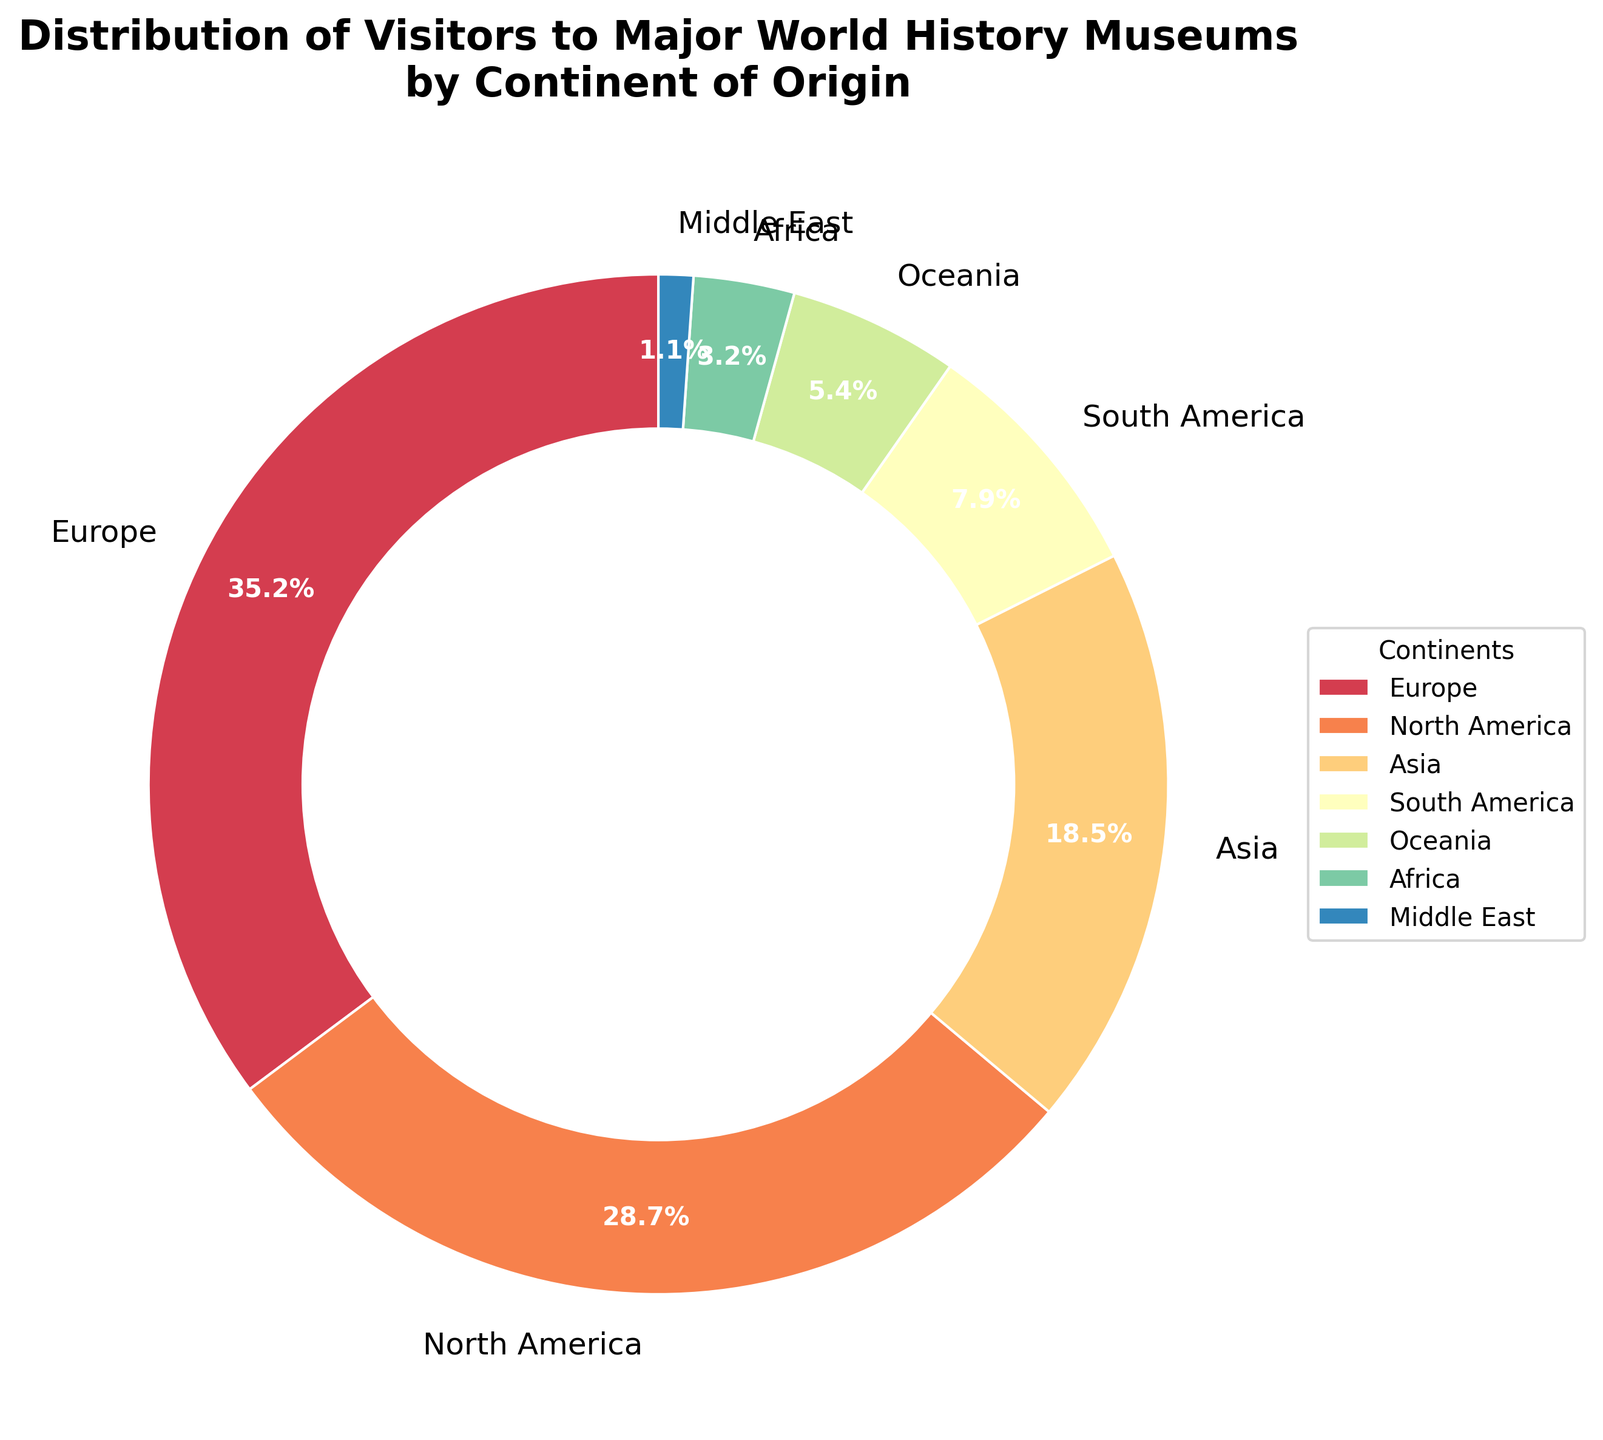What percentage of visitors to major world history museums come from Europe? Identify the segment labeled "Europe" in the pie chart and note its percentage value.
Answer: 35.2% Which continent has the second highest percentage of visitors to major world history museums? The pie chart shows that the continent with the highest percentage of visitors is Europe at 35.2%. The next largest segment is labeled "North America" with 28.7%.
Answer: North America What is the combined percentage of visitors from Asia and South America? Locate the segments labeled "Asia" and "South America" in the pie chart. Add their percentages: 18.5% + 7.9% = 26.4%.
Answer: 26.4% Is the percentage of visitors from Oceania greater than the percentage of visitors from Africa? Compare the values from the pie chart: Oceania is 5.4% and Africa is 3.2%. 5.4% is greater than 3.2%.
Answer: Yes Which three continents contribute the least percentage of visitors to major world history museums? Identify the three smallest segments in the pie chart which are labeled "Middle East" (1.1%), "Africa" (3.2%), and "Oceania" (5.4%).
Answer: Middle East, Africa, Oceania How much higher is the percentage of visitors from North America compared to Oceania? Subtract the percentage of visitors from Oceania from North America: 28.7% - 5.4% = 23.3%.
Answer: 23.3% Which continent has the smallest percentage of visitors, and what is the value? Find the smallest segment in the pie chart which is labeled "Middle East" with 1.1%.
Answer: Middle East, 1.1% What is the total percentage of visitors from continents not in the top three largest segments? The top three largest percentages are Europe (35.2%), North America (28.7%), and Asia (18.5%). Add the remaining percentages: 7.9% (South America) + 5.4% (Oceania) + 3.2% (Africa) + 1.1% (Middle East) = 17.6%.
Answer: 17.6% Among the continents with over 5% visitors, which one has the lowest percentage and what is that percentage? Identify the continents with over 5%: Europe (35.2%), North America (28.7%), Asia (18.5%), South America (7.9%), and Oceania (5.4%). Among those, Oceania has the lowest percentage, which is 5.4%.
Answer: Oceania, 5.4% What is the difference in the percentage of visitors between the continent with the highest value and the continent with the lowest value? Subtract the percentage of the continent with the lowest value (Middle East, 1.1%) from the continent with the highest value (Europe, 35.2%): 35.2% - 1.1% = 34.1%.
Answer: 34.1% 